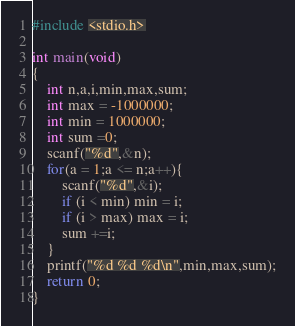<code> <loc_0><loc_0><loc_500><loc_500><_C_>#include <stdio.h>

int main(void)
{
	int n,a,i,min,max,sum;
	int max = -1000000;
	int min = 1000000;
	int sum =0;
	scanf("%d",&n);
	for(a = 1;a <= n;a++){
		scanf("%d",&i);
		if (i < min) min = i;
		if (i > max) max = i;
		sum +=i;
	}
	printf("%d %d %d\n",min,max,sum);
	return 0;
}</code> 